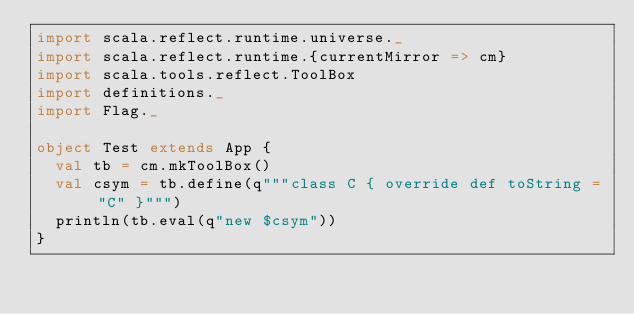Convert code to text. <code><loc_0><loc_0><loc_500><loc_500><_Scala_>import scala.reflect.runtime.universe._
import scala.reflect.runtime.{currentMirror => cm}
import scala.tools.reflect.ToolBox
import definitions._
import Flag._

object Test extends App {
  val tb = cm.mkToolBox()
  val csym = tb.define(q"""class C { override def toString = "C" }""")
  println(tb.eval(q"new $csym"))
}
</code> 